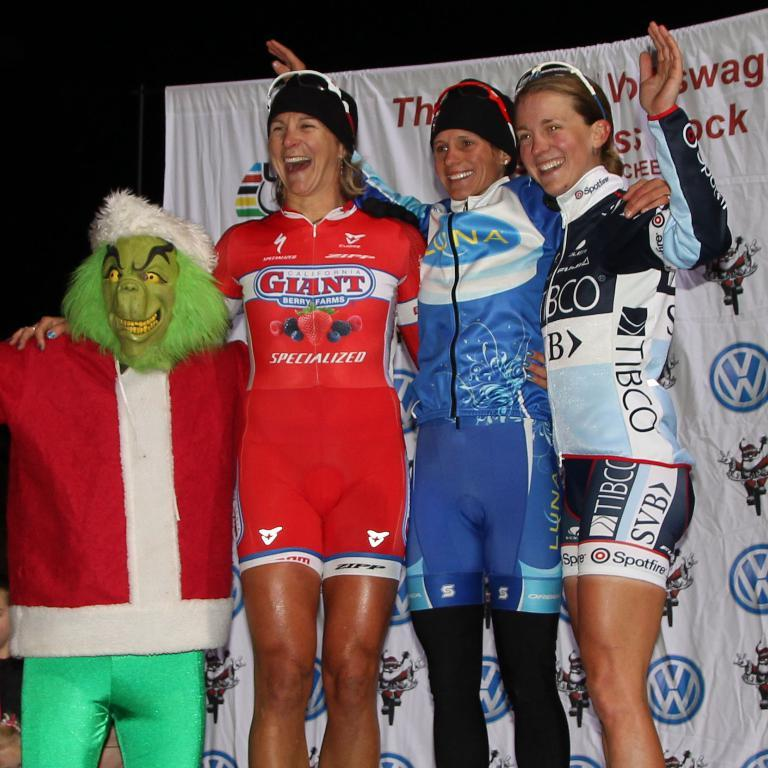<image>
Present a compact description of the photo's key features. A woman wearing an outfit that says giant berry farm is standing next to the grinch 